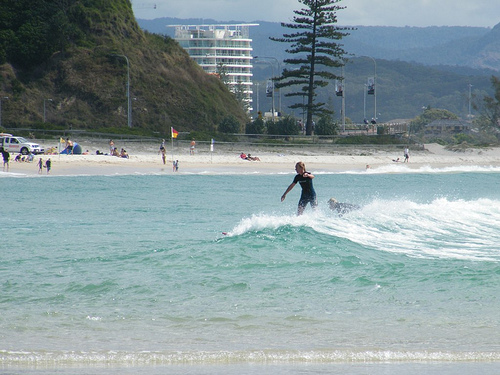Please provide the bounding box coordinate of the region this sentence describes: the flag on the beach. The bounding box coordinates for the flag on the beach are [0.34, 0.37, 0.36, 0.45]. These coordinates pinpoint the area where a flag is stationed on the sandy beach. 